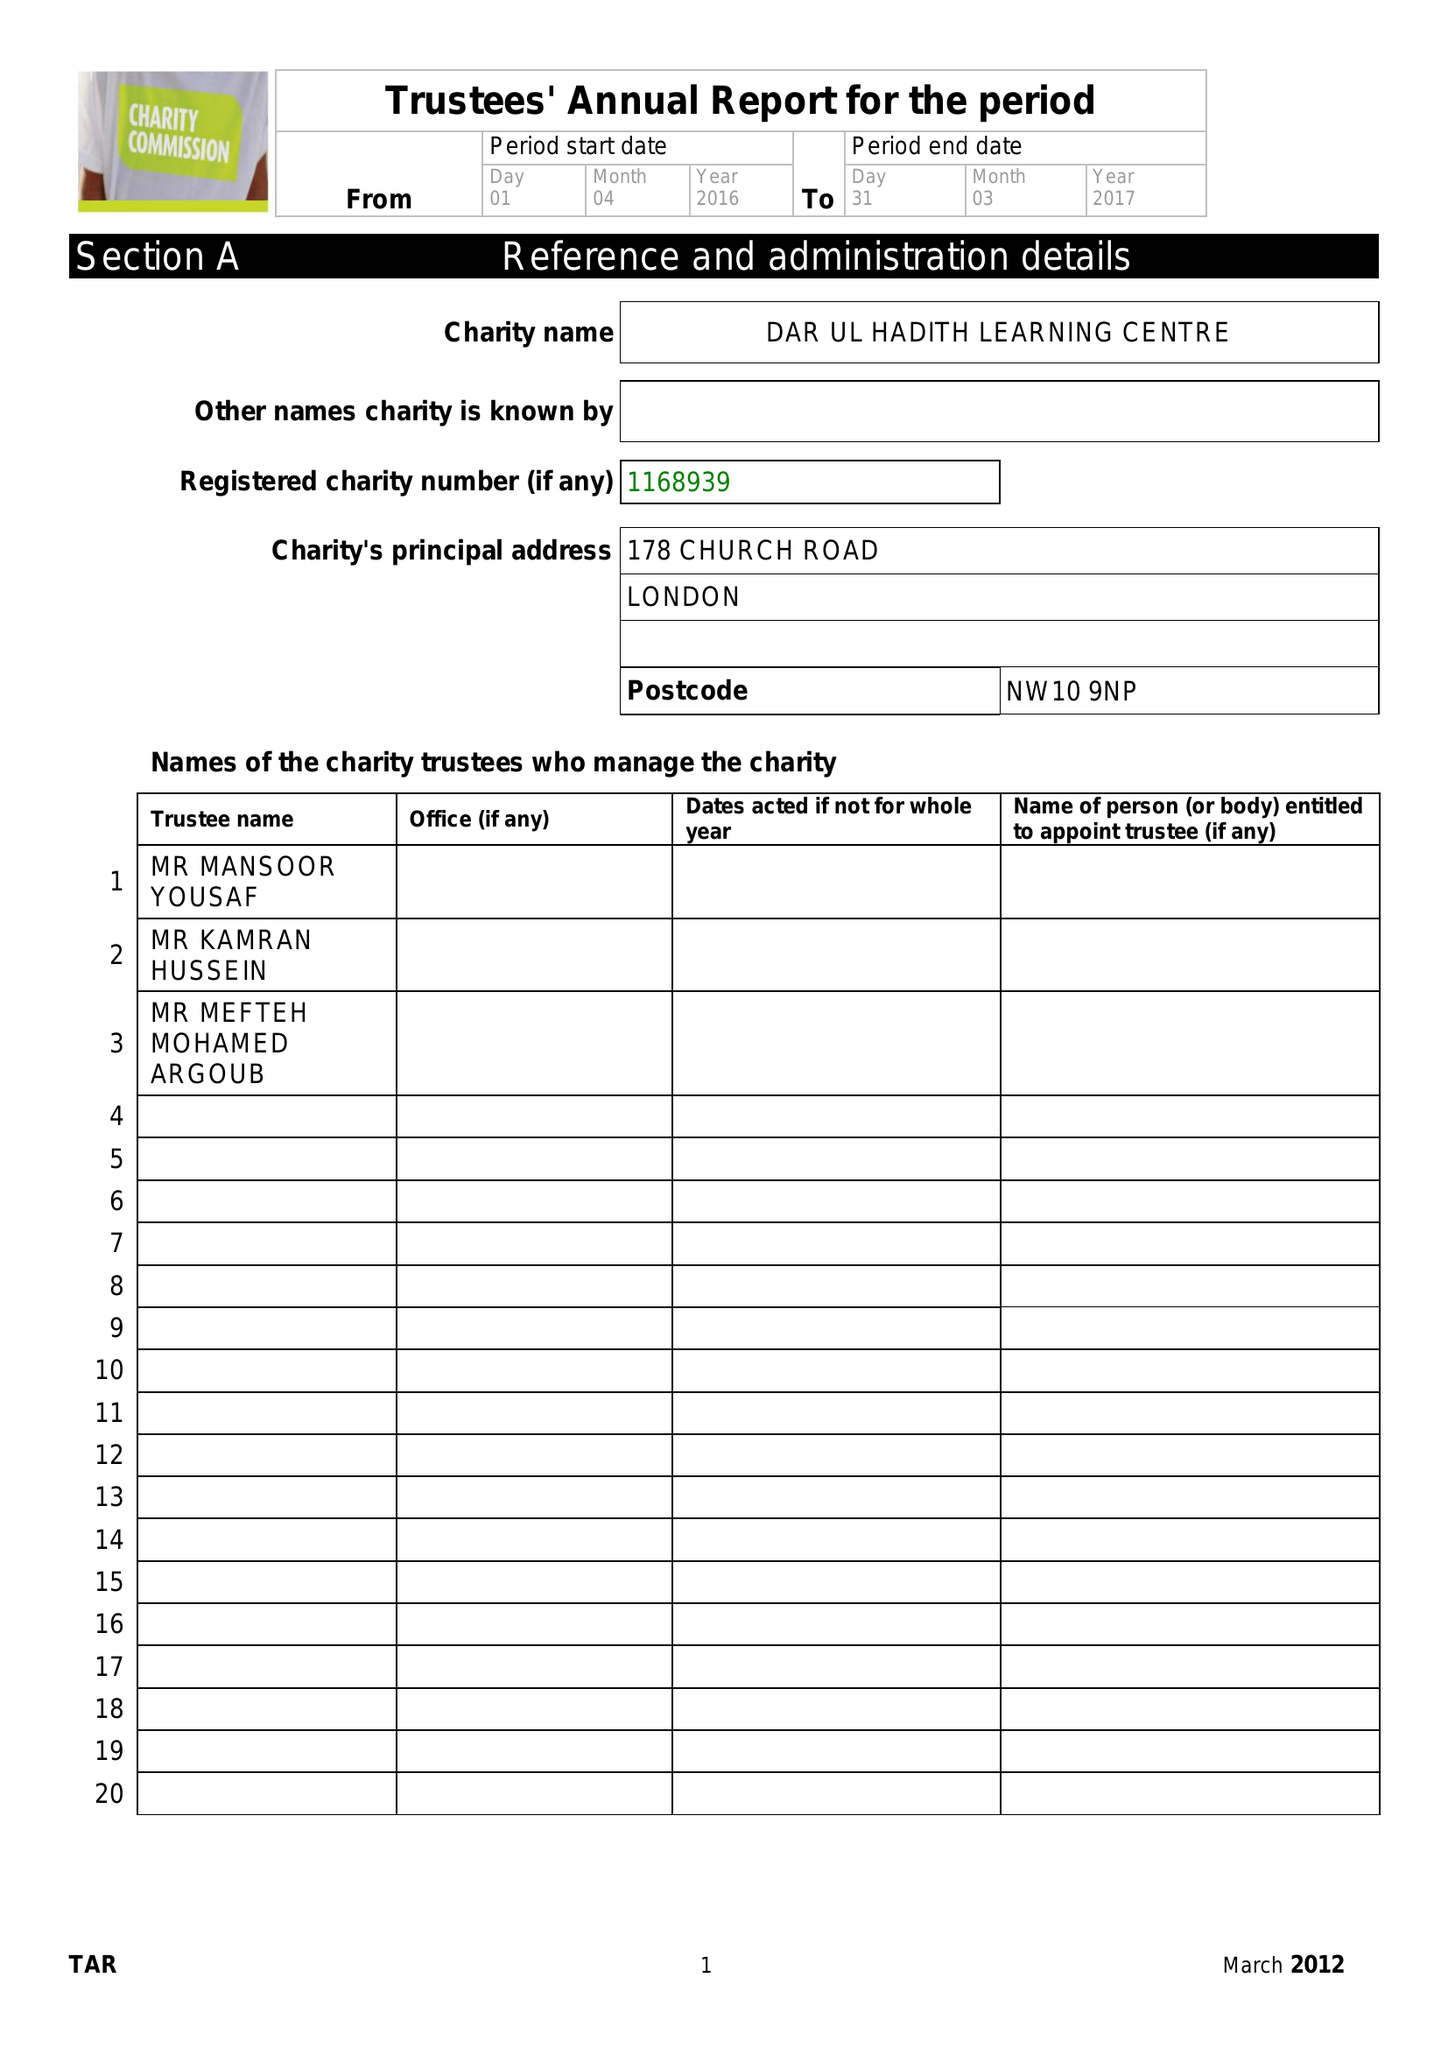What is the value for the address__post_town?
Answer the question using a single word or phrase. LONDON 